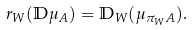<formula> <loc_0><loc_0><loc_500><loc_500>r _ { W } ( \mathbb { D } \mu _ { A } ) = \mathbb { D } _ { W } ( \mu _ { \pi _ { W } A } ) .</formula> 